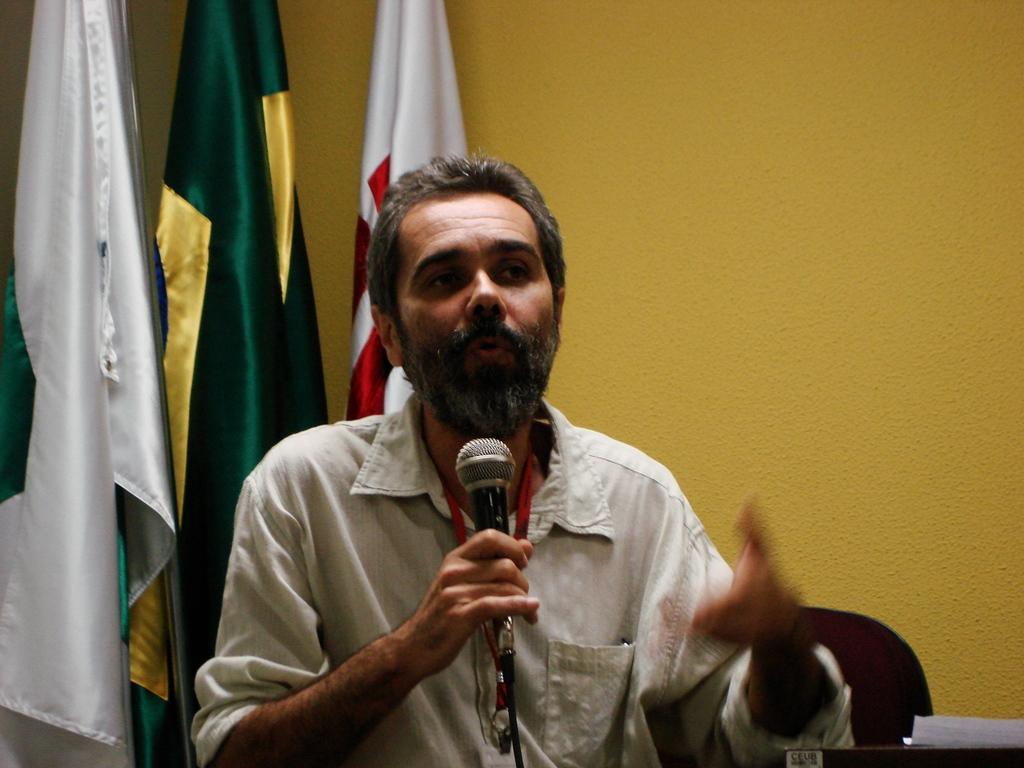How would you summarize this image in a sentence or two? In this picture we can see a man who is holding a mike with his hand. He is talking on the talk. On the background there is a wall. And these are the flags. 